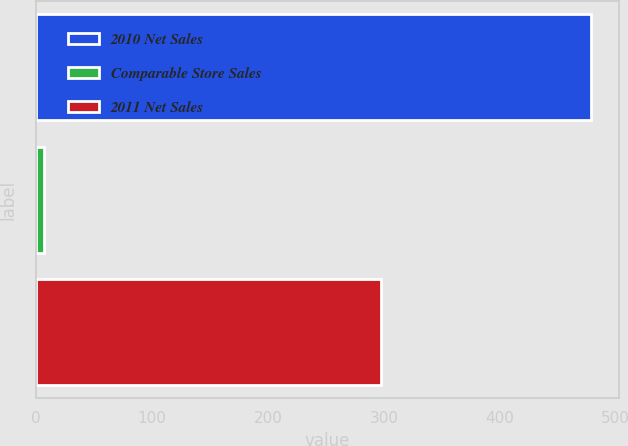<chart> <loc_0><loc_0><loc_500><loc_500><bar_chart><fcel>2010 Net Sales<fcel>Comparable Store Sales<fcel>2011 Net Sales<nl><fcel>479<fcel>7<fcel>298<nl></chart> 